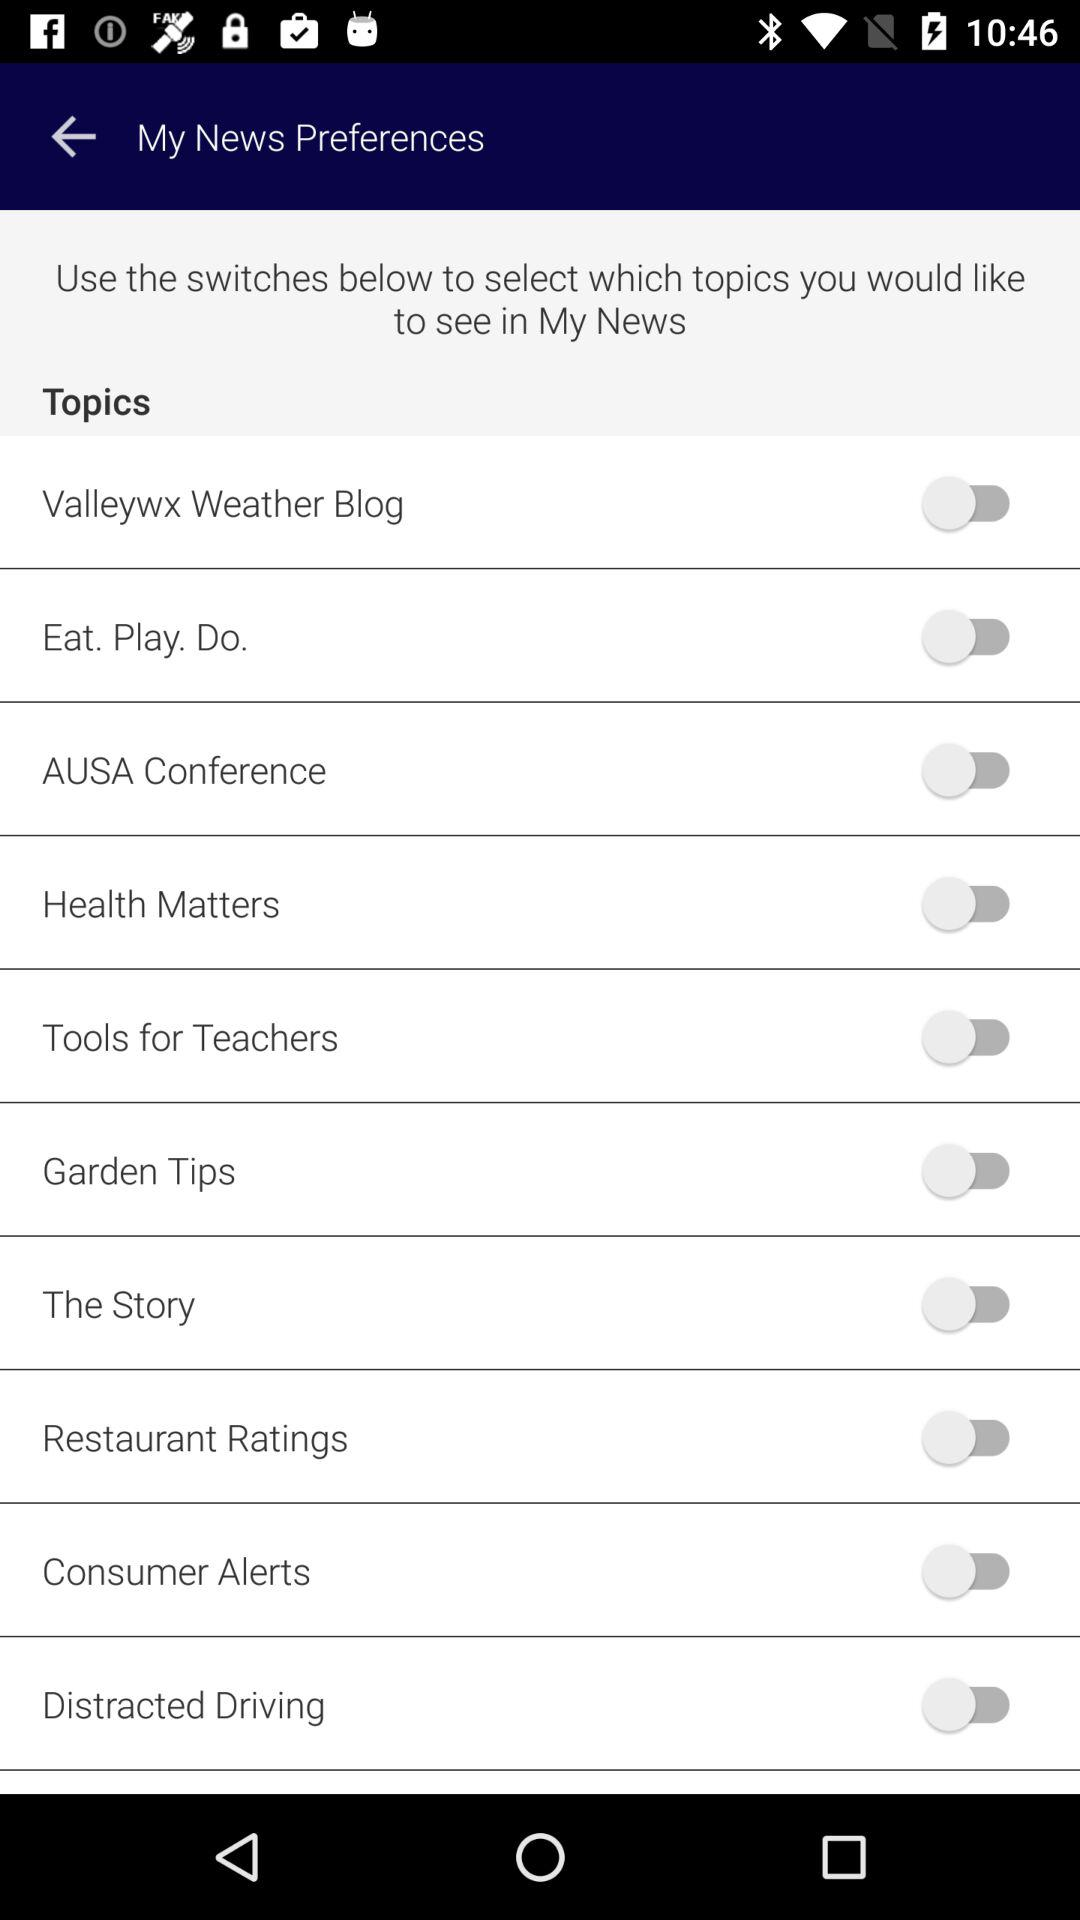How many topics are there in total?
Answer the question using a single word or phrase. 10 